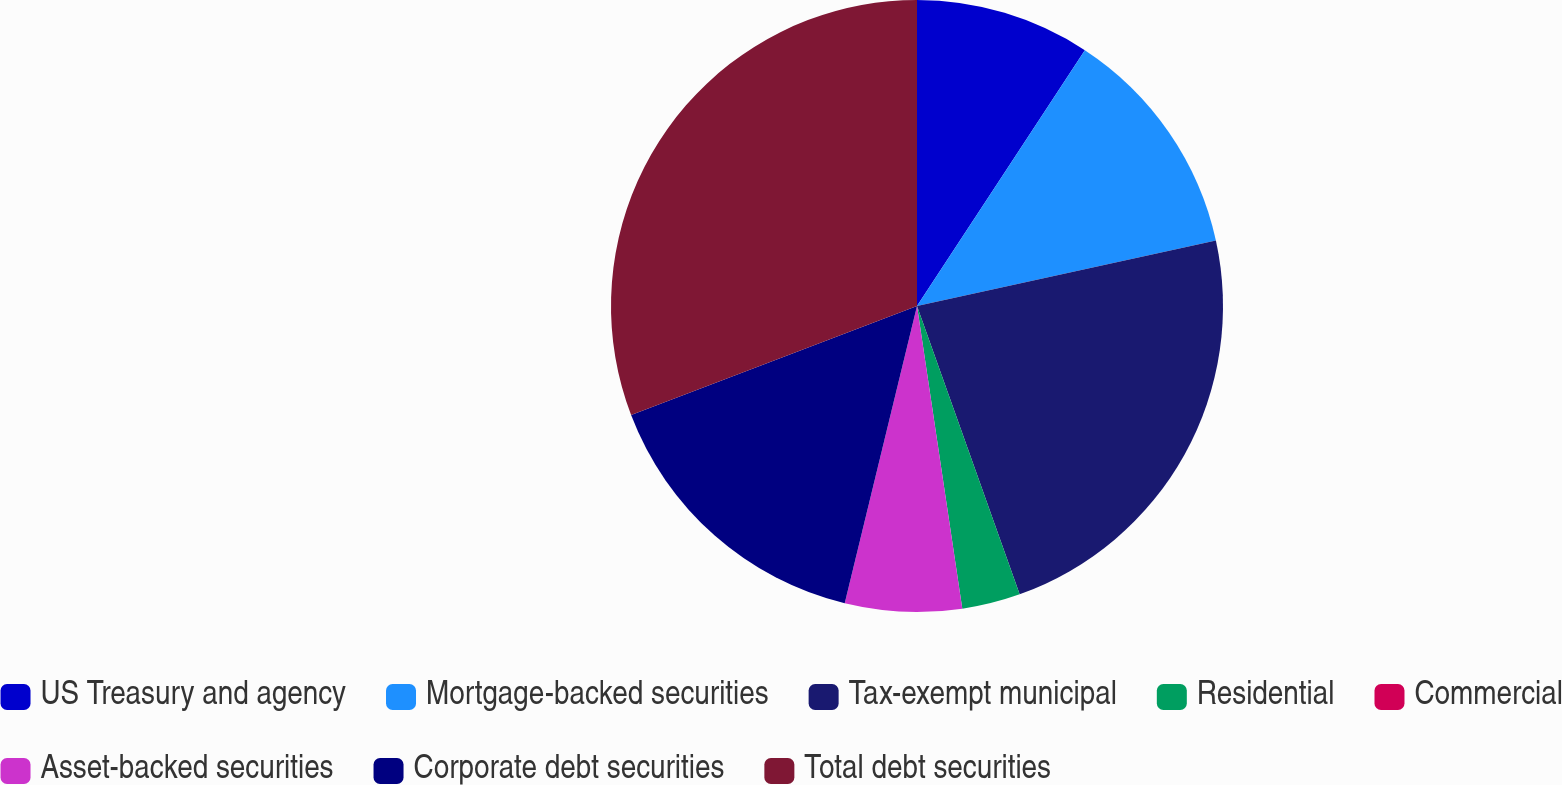Convert chart. <chart><loc_0><loc_0><loc_500><loc_500><pie_chart><fcel>US Treasury and agency<fcel>Mortgage-backed securities<fcel>Tax-exempt municipal<fcel>Residential<fcel>Commercial<fcel>Asset-backed securities<fcel>Corporate debt securities<fcel>Total debt securities<nl><fcel>9.24%<fcel>12.32%<fcel>22.99%<fcel>3.08%<fcel>0.0%<fcel>6.16%<fcel>15.4%<fcel>30.8%<nl></chart> 